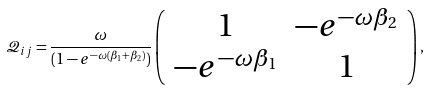Convert formula to latex. <formula><loc_0><loc_0><loc_500><loc_500>\mathcal { Q } _ { i j } = \frac { \omega } { ( 1 - e ^ { - \omega ( \beta _ { 1 } + \beta _ { 2 } ) } ) } \left ( \begin{array} { c c } 1 & - e ^ { - \omega \beta _ { 2 } } \\ - e ^ { - \omega \beta _ { 1 } } & 1 \end{array} \right ) ,</formula> 